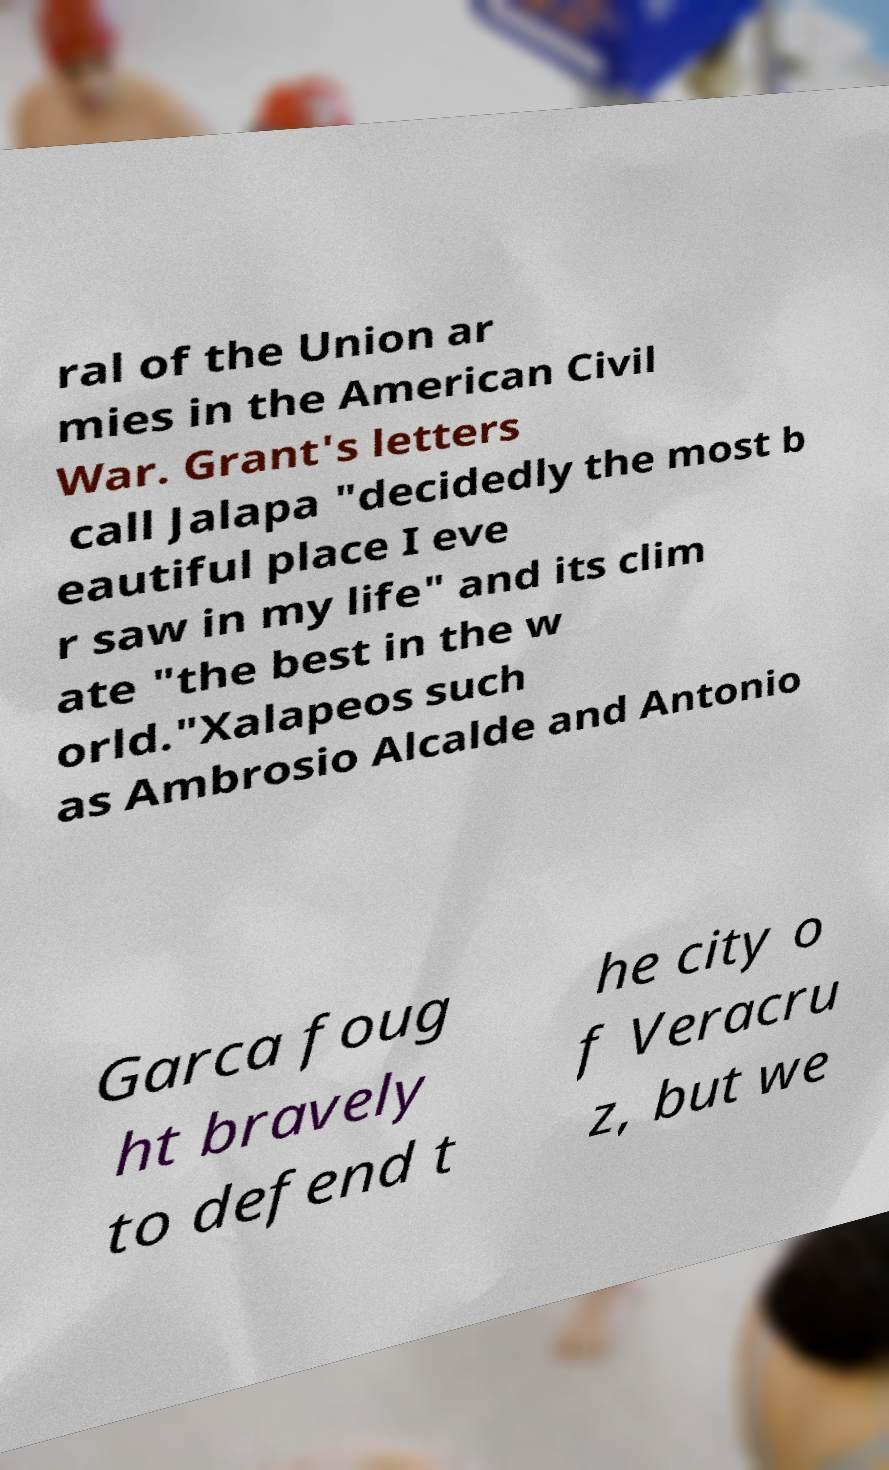What messages or text are displayed in this image? I need them in a readable, typed format. ral of the Union ar mies in the American Civil War. Grant's letters call Jalapa "decidedly the most b eautiful place I eve r saw in my life" and its clim ate "the best in the w orld."Xalapeos such as Ambrosio Alcalde and Antonio Garca foug ht bravely to defend t he city o f Veracru z, but we 